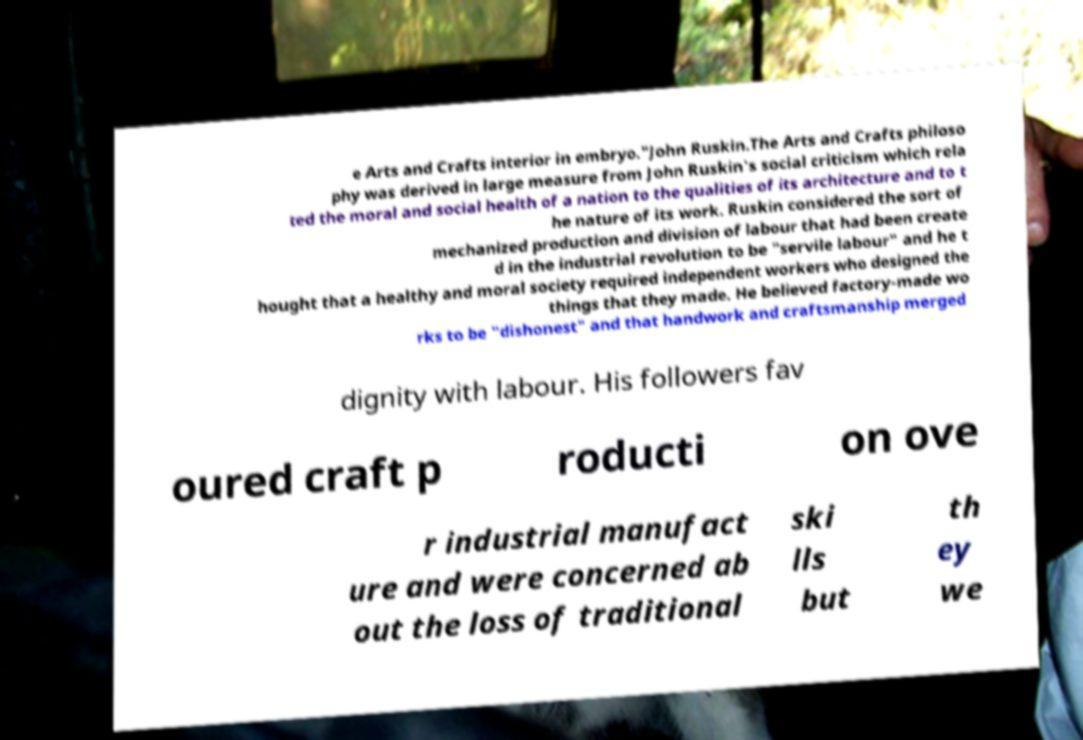Please read and relay the text visible in this image. What does it say? e Arts and Crafts interior in embryo."John Ruskin.The Arts and Crafts philoso phy was derived in large measure from John Ruskin's social criticism which rela ted the moral and social health of a nation to the qualities of its architecture and to t he nature of its work. Ruskin considered the sort of mechanized production and division of labour that had been create d in the industrial revolution to be "servile labour" and he t hought that a healthy and moral society required independent workers who designed the things that they made. He believed factory-made wo rks to be "dishonest" and that handwork and craftsmanship merged dignity with labour. His followers fav oured craft p roducti on ove r industrial manufact ure and were concerned ab out the loss of traditional ski lls but th ey we 